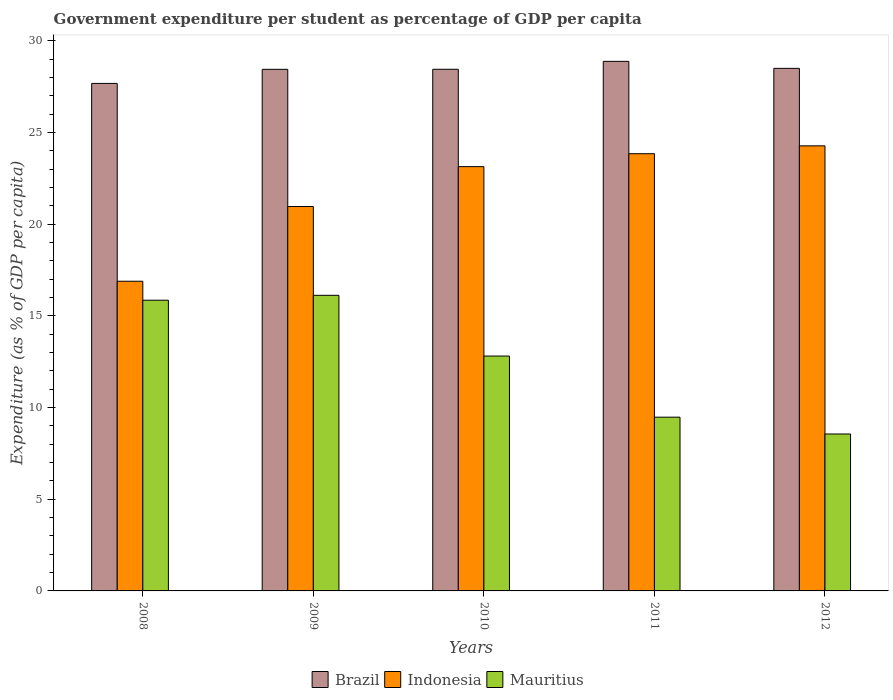How many different coloured bars are there?
Your answer should be very brief. 3. Are the number of bars per tick equal to the number of legend labels?
Provide a short and direct response. Yes. Are the number of bars on each tick of the X-axis equal?
Give a very brief answer. Yes. How many bars are there on the 4th tick from the left?
Offer a terse response. 3. What is the label of the 2nd group of bars from the left?
Your answer should be very brief. 2009. In how many cases, is the number of bars for a given year not equal to the number of legend labels?
Your answer should be very brief. 0. What is the percentage of expenditure per student in Indonesia in 2009?
Make the answer very short. 20.96. Across all years, what is the maximum percentage of expenditure per student in Brazil?
Make the answer very short. 28.87. Across all years, what is the minimum percentage of expenditure per student in Brazil?
Ensure brevity in your answer.  27.67. What is the total percentage of expenditure per student in Mauritius in the graph?
Keep it short and to the point. 62.8. What is the difference between the percentage of expenditure per student in Mauritius in 2009 and that in 2012?
Your response must be concise. 7.56. What is the difference between the percentage of expenditure per student in Indonesia in 2010 and the percentage of expenditure per student in Mauritius in 2012?
Keep it short and to the point. 14.58. What is the average percentage of expenditure per student in Mauritius per year?
Ensure brevity in your answer.  12.56. In the year 2011, what is the difference between the percentage of expenditure per student in Mauritius and percentage of expenditure per student in Indonesia?
Make the answer very short. -14.36. In how many years, is the percentage of expenditure per student in Mauritius greater than 17 %?
Your response must be concise. 0. What is the ratio of the percentage of expenditure per student in Mauritius in 2009 to that in 2010?
Provide a succinct answer. 1.26. What is the difference between the highest and the second highest percentage of expenditure per student in Indonesia?
Keep it short and to the point. 0.43. What is the difference between the highest and the lowest percentage of expenditure per student in Brazil?
Make the answer very short. 1.2. In how many years, is the percentage of expenditure per student in Indonesia greater than the average percentage of expenditure per student in Indonesia taken over all years?
Offer a very short reply. 3. Is the sum of the percentage of expenditure per student in Brazil in 2009 and 2011 greater than the maximum percentage of expenditure per student in Mauritius across all years?
Your response must be concise. Yes. What does the 1st bar from the right in 2008 represents?
Offer a terse response. Mauritius. How many bars are there?
Give a very brief answer. 15. Are all the bars in the graph horizontal?
Offer a terse response. No. Are the values on the major ticks of Y-axis written in scientific E-notation?
Provide a succinct answer. No. Does the graph contain grids?
Provide a short and direct response. No. How are the legend labels stacked?
Make the answer very short. Horizontal. What is the title of the graph?
Offer a terse response. Government expenditure per student as percentage of GDP per capita. Does "Hungary" appear as one of the legend labels in the graph?
Provide a short and direct response. No. What is the label or title of the Y-axis?
Give a very brief answer. Expenditure (as % of GDP per capita). What is the Expenditure (as % of GDP per capita) in Brazil in 2008?
Your answer should be compact. 27.67. What is the Expenditure (as % of GDP per capita) in Indonesia in 2008?
Offer a terse response. 16.89. What is the Expenditure (as % of GDP per capita) of Mauritius in 2008?
Your answer should be compact. 15.85. What is the Expenditure (as % of GDP per capita) of Brazil in 2009?
Keep it short and to the point. 28.44. What is the Expenditure (as % of GDP per capita) in Indonesia in 2009?
Your answer should be compact. 20.96. What is the Expenditure (as % of GDP per capita) of Mauritius in 2009?
Your answer should be compact. 16.12. What is the Expenditure (as % of GDP per capita) in Brazil in 2010?
Ensure brevity in your answer.  28.44. What is the Expenditure (as % of GDP per capita) of Indonesia in 2010?
Your answer should be compact. 23.13. What is the Expenditure (as % of GDP per capita) in Mauritius in 2010?
Keep it short and to the point. 12.81. What is the Expenditure (as % of GDP per capita) in Brazil in 2011?
Offer a very short reply. 28.87. What is the Expenditure (as % of GDP per capita) in Indonesia in 2011?
Provide a short and direct response. 23.84. What is the Expenditure (as % of GDP per capita) in Mauritius in 2011?
Your answer should be very brief. 9.47. What is the Expenditure (as % of GDP per capita) in Brazil in 2012?
Your response must be concise. 28.49. What is the Expenditure (as % of GDP per capita) of Indonesia in 2012?
Your answer should be compact. 24.27. What is the Expenditure (as % of GDP per capita) of Mauritius in 2012?
Offer a terse response. 8.56. Across all years, what is the maximum Expenditure (as % of GDP per capita) in Brazil?
Offer a very short reply. 28.87. Across all years, what is the maximum Expenditure (as % of GDP per capita) of Indonesia?
Provide a succinct answer. 24.27. Across all years, what is the maximum Expenditure (as % of GDP per capita) in Mauritius?
Offer a terse response. 16.12. Across all years, what is the minimum Expenditure (as % of GDP per capita) in Brazil?
Keep it short and to the point. 27.67. Across all years, what is the minimum Expenditure (as % of GDP per capita) in Indonesia?
Provide a short and direct response. 16.89. Across all years, what is the minimum Expenditure (as % of GDP per capita) in Mauritius?
Ensure brevity in your answer.  8.56. What is the total Expenditure (as % of GDP per capita) in Brazil in the graph?
Your answer should be very brief. 141.92. What is the total Expenditure (as % of GDP per capita) in Indonesia in the graph?
Your response must be concise. 109.08. What is the total Expenditure (as % of GDP per capita) in Mauritius in the graph?
Offer a terse response. 62.8. What is the difference between the Expenditure (as % of GDP per capita) in Brazil in 2008 and that in 2009?
Your answer should be compact. -0.77. What is the difference between the Expenditure (as % of GDP per capita) in Indonesia in 2008 and that in 2009?
Offer a very short reply. -4.07. What is the difference between the Expenditure (as % of GDP per capita) of Mauritius in 2008 and that in 2009?
Keep it short and to the point. -0.27. What is the difference between the Expenditure (as % of GDP per capita) in Brazil in 2008 and that in 2010?
Your answer should be compact. -0.77. What is the difference between the Expenditure (as % of GDP per capita) in Indonesia in 2008 and that in 2010?
Offer a terse response. -6.25. What is the difference between the Expenditure (as % of GDP per capita) of Mauritius in 2008 and that in 2010?
Offer a terse response. 3.04. What is the difference between the Expenditure (as % of GDP per capita) of Brazil in 2008 and that in 2011?
Give a very brief answer. -1.2. What is the difference between the Expenditure (as % of GDP per capita) of Indonesia in 2008 and that in 2011?
Offer a terse response. -6.95. What is the difference between the Expenditure (as % of GDP per capita) in Mauritius in 2008 and that in 2011?
Make the answer very short. 6.38. What is the difference between the Expenditure (as % of GDP per capita) of Brazil in 2008 and that in 2012?
Provide a short and direct response. -0.82. What is the difference between the Expenditure (as % of GDP per capita) of Indonesia in 2008 and that in 2012?
Give a very brief answer. -7.38. What is the difference between the Expenditure (as % of GDP per capita) of Mauritius in 2008 and that in 2012?
Provide a short and direct response. 7.29. What is the difference between the Expenditure (as % of GDP per capita) of Brazil in 2009 and that in 2010?
Your response must be concise. -0. What is the difference between the Expenditure (as % of GDP per capita) in Indonesia in 2009 and that in 2010?
Your answer should be compact. -2.17. What is the difference between the Expenditure (as % of GDP per capita) in Mauritius in 2009 and that in 2010?
Keep it short and to the point. 3.31. What is the difference between the Expenditure (as % of GDP per capita) in Brazil in 2009 and that in 2011?
Ensure brevity in your answer.  -0.43. What is the difference between the Expenditure (as % of GDP per capita) in Indonesia in 2009 and that in 2011?
Ensure brevity in your answer.  -2.88. What is the difference between the Expenditure (as % of GDP per capita) in Mauritius in 2009 and that in 2011?
Give a very brief answer. 6.64. What is the difference between the Expenditure (as % of GDP per capita) of Brazil in 2009 and that in 2012?
Provide a short and direct response. -0.05. What is the difference between the Expenditure (as % of GDP per capita) in Indonesia in 2009 and that in 2012?
Provide a short and direct response. -3.31. What is the difference between the Expenditure (as % of GDP per capita) in Mauritius in 2009 and that in 2012?
Give a very brief answer. 7.56. What is the difference between the Expenditure (as % of GDP per capita) in Brazil in 2010 and that in 2011?
Your answer should be compact. -0.43. What is the difference between the Expenditure (as % of GDP per capita) of Indonesia in 2010 and that in 2011?
Offer a very short reply. -0.7. What is the difference between the Expenditure (as % of GDP per capita) of Mauritius in 2010 and that in 2011?
Your response must be concise. 3.33. What is the difference between the Expenditure (as % of GDP per capita) in Brazil in 2010 and that in 2012?
Ensure brevity in your answer.  -0.05. What is the difference between the Expenditure (as % of GDP per capita) of Indonesia in 2010 and that in 2012?
Offer a very short reply. -1.13. What is the difference between the Expenditure (as % of GDP per capita) in Mauritius in 2010 and that in 2012?
Keep it short and to the point. 4.25. What is the difference between the Expenditure (as % of GDP per capita) of Brazil in 2011 and that in 2012?
Keep it short and to the point. 0.38. What is the difference between the Expenditure (as % of GDP per capita) of Indonesia in 2011 and that in 2012?
Your answer should be very brief. -0.43. What is the difference between the Expenditure (as % of GDP per capita) in Mauritius in 2011 and that in 2012?
Make the answer very short. 0.92. What is the difference between the Expenditure (as % of GDP per capita) of Brazil in 2008 and the Expenditure (as % of GDP per capita) of Indonesia in 2009?
Your answer should be compact. 6.71. What is the difference between the Expenditure (as % of GDP per capita) of Brazil in 2008 and the Expenditure (as % of GDP per capita) of Mauritius in 2009?
Ensure brevity in your answer.  11.55. What is the difference between the Expenditure (as % of GDP per capita) of Indonesia in 2008 and the Expenditure (as % of GDP per capita) of Mauritius in 2009?
Your answer should be compact. 0.77. What is the difference between the Expenditure (as % of GDP per capita) in Brazil in 2008 and the Expenditure (as % of GDP per capita) in Indonesia in 2010?
Make the answer very short. 4.54. What is the difference between the Expenditure (as % of GDP per capita) in Brazil in 2008 and the Expenditure (as % of GDP per capita) in Mauritius in 2010?
Your answer should be compact. 14.86. What is the difference between the Expenditure (as % of GDP per capita) in Indonesia in 2008 and the Expenditure (as % of GDP per capita) in Mauritius in 2010?
Provide a short and direct response. 4.08. What is the difference between the Expenditure (as % of GDP per capita) in Brazil in 2008 and the Expenditure (as % of GDP per capita) in Indonesia in 2011?
Offer a very short reply. 3.83. What is the difference between the Expenditure (as % of GDP per capita) in Brazil in 2008 and the Expenditure (as % of GDP per capita) in Mauritius in 2011?
Make the answer very short. 18.2. What is the difference between the Expenditure (as % of GDP per capita) of Indonesia in 2008 and the Expenditure (as % of GDP per capita) of Mauritius in 2011?
Ensure brevity in your answer.  7.41. What is the difference between the Expenditure (as % of GDP per capita) of Brazil in 2008 and the Expenditure (as % of GDP per capita) of Indonesia in 2012?
Provide a short and direct response. 3.4. What is the difference between the Expenditure (as % of GDP per capita) in Brazil in 2008 and the Expenditure (as % of GDP per capita) in Mauritius in 2012?
Make the answer very short. 19.11. What is the difference between the Expenditure (as % of GDP per capita) of Indonesia in 2008 and the Expenditure (as % of GDP per capita) of Mauritius in 2012?
Your response must be concise. 8.33. What is the difference between the Expenditure (as % of GDP per capita) in Brazil in 2009 and the Expenditure (as % of GDP per capita) in Indonesia in 2010?
Offer a terse response. 5.31. What is the difference between the Expenditure (as % of GDP per capita) of Brazil in 2009 and the Expenditure (as % of GDP per capita) of Mauritius in 2010?
Keep it short and to the point. 15.63. What is the difference between the Expenditure (as % of GDP per capita) in Indonesia in 2009 and the Expenditure (as % of GDP per capita) in Mauritius in 2010?
Offer a very short reply. 8.15. What is the difference between the Expenditure (as % of GDP per capita) in Brazil in 2009 and the Expenditure (as % of GDP per capita) in Indonesia in 2011?
Ensure brevity in your answer.  4.6. What is the difference between the Expenditure (as % of GDP per capita) in Brazil in 2009 and the Expenditure (as % of GDP per capita) in Mauritius in 2011?
Provide a short and direct response. 18.97. What is the difference between the Expenditure (as % of GDP per capita) of Indonesia in 2009 and the Expenditure (as % of GDP per capita) of Mauritius in 2011?
Give a very brief answer. 11.49. What is the difference between the Expenditure (as % of GDP per capita) of Brazil in 2009 and the Expenditure (as % of GDP per capita) of Indonesia in 2012?
Provide a succinct answer. 4.17. What is the difference between the Expenditure (as % of GDP per capita) of Brazil in 2009 and the Expenditure (as % of GDP per capita) of Mauritius in 2012?
Your answer should be compact. 19.88. What is the difference between the Expenditure (as % of GDP per capita) in Indonesia in 2009 and the Expenditure (as % of GDP per capita) in Mauritius in 2012?
Your answer should be very brief. 12.4. What is the difference between the Expenditure (as % of GDP per capita) in Brazil in 2010 and the Expenditure (as % of GDP per capita) in Indonesia in 2011?
Provide a succinct answer. 4.6. What is the difference between the Expenditure (as % of GDP per capita) in Brazil in 2010 and the Expenditure (as % of GDP per capita) in Mauritius in 2011?
Your answer should be compact. 18.97. What is the difference between the Expenditure (as % of GDP per capita) of Indonesia in 2010 and the Expenditure (as % of GDP per capita) of Mauritius in 2011?
Give a very brief answer. 13.66. What is the difference between the Expenditure (as % of GDP per capita) in Brazil in 2010 and the Expenditure (as % of GDP per capita) in Indonesia in 2012?
Make the answer very short. 4.18. What is the difference between the Expenditure (as % of GDP per capita) in Brazil in 2010 and the Expenditure (as % of GDP per capita) in Mauritius in 2012?
Ensure brevity in your answer.  19.89. What is the difference between the Expenditure (as % of GDP per capita) of Indonesia in 2010 and the Expenditure (as % of GDP per capita) of Mauritius in 2012?
Offer a terse response. 14.58. What is the difference between the Expenditure (as % of GDP per capita) of Brazil in 2011 and the Expenditure (as % of GDP per capita) of Indonesia in 2012?
Give a very brief answer. 4.61. What is the difference between the Expenditure (as % of GDP per capita) in Brazil in 2011 and the Expenditure (as % of GDP per capita) in Mauritius in 2012?
Offer a very short reply. 20.32. What is the difference between the Expenditure (as % of GDP per capita) of Indonesia in 2011 and the Expenditure (as % of GDP per capita) of Mauritius in 2012?
Make the answer very short. 15.28. What is the average Expenditure (as % of GDP per capita) in Brazil per year?
Provide a short and direct response. 28.38. What is the average Expenditure (as % of GDP per capita) of Indonesia per year?
Offer a terse response. 21.82. What is the average Expenditure (as % of GDP per capita) in Mauritius per year?
Your answer should be compact. 12.56. In the year 2008, what is the difference between the Expenditure (as % of GDP per capita) of Brazil and Expenditure (as % of GDP per capita) of Indonesia?
Make the answer very short. 10.79. In the year 2008, what is the difference between the Expenditure (as % of GDP per capita) in Brazil and Expenditure (as % of GDP per capita) in Mauritius?
Offer a terse response. 11.82. In the year 2008, what is the difference between the Expenditure (as % of GDP per capita) of Indonesia and Expenditure (as % of GDP per capita) of Mauritius?
Make the answer very short. 1.03. In the year 2009, what is the difference between the Expenditure (as % of GDP per capita) of Brazil and Expenditure (as % of GDP per capita) of Indonesia?
Ensure brevity in your answer.  7.48. In the year 2009, what is the difference between the Expenditure (as % of GDP per capita) of Brazil and Expenditure (as % of GDP per capita) of Mauritius?
Offer a very short reply. 12.32. In the year 2009, what is the difference between the Expenditure (as % of GDP per capita) in Indonesia and Expenditure (as % of GDP per capita) in Mauritius?
Your answer should be very brief. 4.84. In the year 2010, what is the difference between the Expenditure (as % of GDP per capita) of Brazil and Expenditure (as % of GDP per capita) of Indonesia?
Make the answer very short. 5.31. In the year 2010, what is the difference between the Expenditure (as % of GDP per capita) of Brazil and Expenditure (as % of GDP per capita) of Mauritius?
Provide a succinct answer. 15.64. In the year 2010, what is the difference between the Expenditure (as % of GDP per capita) of Indonesia and Expenditure (as % of GDP per capita) of Mauritius?
Offer a very short reply. 10.33. In the year 2011, what is the difference between the Expenditure (as % of GDP per capita) in Brazil and Expenditure (as % of GDP per capita) in Indonesia?
Your answer should be very brief. 5.04. In the year 2011, what is the difference between the Expenditure (as % of GDP per capita) of Brazil and Expenditure (as % of GDP per capita) of Mauritius?
Offer a terse response. 19.4. In the year 2011, what is the difference between the Expenditure (as % of GDP per capita) of Indonesia and Expenditure (as % of GDP per capita) of Mauritius?
Your answer should be very brief. 14.36. In the year 2012, what is the difference between the Expenditure (as % of GDP per capita) of Brazil and Expenditure (as % of GDP per capita) of Indonesia?
Provide a succinct answer. 4.23. In the year 2012, what is the difference between the Expenditure (as % of GDP per capita) of Brazil and Expenditure (as % of GDP per capita) of Mauritius?
Give a very brief answer. 19.94. In the year 2012, what is the difference between the Expenditure (as % of GDP per capita) of Indonesia and Expenditure (as % of GDP per capita) of Mauritius?
Your response must be concise. 15.71. What is the ratio of the Expenditure (as % of GDP per capita) in Indonesia in 2008 to that in 2009?
Your answer should be very brief. 0.81. What is the ratio of the Expenditure (as % of GDP per capita) of Mauritius in 2008 to that in 2009?
Make the answer very short. 0.98. What is the ratio of the Expenditure (as % of GDP per capita) of Brazil in 2008 to that in 2010?
Provide a short and direct response. 0.97. What is the ratio of the Expenditure (as % of GDP per capita) in Indonesia in 2008 to that in 2010?
Keep it short and to the point. 0.73. What is the ratio of the Expenditure (as % of GDP per capita) in Mauritius in 2008 to that in 2010?
Give a very brief answer. 1.24. What is the ratio of the Expenditure (as % of GDP per capita) of Brazil in 2008 to that in 2011?
Provide a short and direct response. 0.96. What is the ratio of the Expenditure (as % of GDP per capita) in Indonesia in 2008 to that in 2011?
Provide a succinct answer. 0.71. What is the ratio of the Expenditure (as % of GDP per capita) of Mauritius in 2008 to that in 2011?
Make the answer very short. 1.67. What is the ratio of the Expenditure (as % of GDP per capita) of Brazil in 2008 to that in 2012?
Ensure brevity in your answer.  0.97. What is the ratio of the Expenditure (as % of GDP per capita) of Indonesia in 2008 to that in 2012?
Offer a terse response. 0.7. What is the ratio of the Expenditure (as % of GDP per capita) of Mauritius in 2008 to that in 2012?
Keep it short and to the point. 1.85. What is the ratio of the Expenditure (as % of GDP per capita) of Indonesia in 2009 to that in 2010?
Your answer should be compact. 0.91. What is the ratio of the Expenditure (as % of GDP per capita) in Mauritius in 2009 to that in 2010?
Ensure brevity in your answer.  1.26. What is the ratio of the Expenditure (as % of GDP per capita) of Brazil in 2009 to that in 2011?
Provide a succinct answer. 0.98. What is the ratio of the Expenditure (as % of GDP per capita) of Indonesia in 2009 to that in 2011?
Offer a terse response. 0.88. What is the ratio of the Expenditure (as % of GDP per capita) in Mauritius in 2009 to that in 2011?
Provide a short and direct response. 1.7. What is the ratio of the Expenditure (as % of GDP per capita) of Indonesia in 2009 to that in 2012?
Your answer should be very brief. 0.86. What is the ratio of the Expenditure (as % of GDP per capita) of Mauritius in 2009 to that in 2012?
Your response must be concise. 1.88. What is the ratio of the Expenditure (as % of GDP per capita) of Brazil in 2010 to that in 2011?
Give a very brief answer. 0.99. What is the ratio of the Expenditure (as % of GDP per capita) of Indonesia in 2010 to that in 2011?
Keep it short and to the point. 0.97. What is the ratio of the Expenditure (as % of GDP per capita) of Mauritius in 2010 to that in 2011?
Provide a succinct answer. 1.35. What is the ratio of the Expenditure (as % of GDP per capita) of Brazil in 2010 to that in 2012?
Provide a succinct answer. 1. What is the ratio of the Expenditure (as % of GDP per capita) of Indonesia in 2010 to that in 2012?
Provide a short and direct response. 0.95. What is the ratio of the Expenditure (as % of GDP per capita) in Mauritius in 2010 to that in 2012?
Your answer should be very brief. 1.5. What is the ratio of the Expenditure (as % of GDP per capita) in Brazil in 2011 to that in 2012?
Your answer should be compact. 1.01. What is the ratio of the Expenditure (as % of GDP per capita) of Indonesia in 2011 to that in 2012?
Ensure brevity in your answer.  0.98. What is the ratio of the Expenditure (as % of GDP per capita) in Mauritius in 2011 to that in 2012?
Your answer should be very brief. 1.11. What is the difference between the highest and the second highest Expenditure (as % of GDP per capita) in Brazil?
Your response must be concise. 0.38. What is the difference between the highest and the second highest Expenditure (as % of GDP per capita) of Indonesia?
Provide a succinct answer. 0.43. What is the difference between the highest and the second highest Expenditure (as % of GDP per capita) of Mauritius?
Ensure brevity in your answer.  0.27. What is the difference between the highest and the lowest Expenditure (as % of GDP per capita) in Brazil?
Make the answer very short. 1.2. What is the difference between the highest and the lowest Expenditure (as % of GDP per capita) of Indonesia?
Keep it short and to the point. 7.38. What is the difference between the highest and the lowest Expenditure (as % of GDP per capita) in Mauritius?
Make the answer very short. 7.56. 